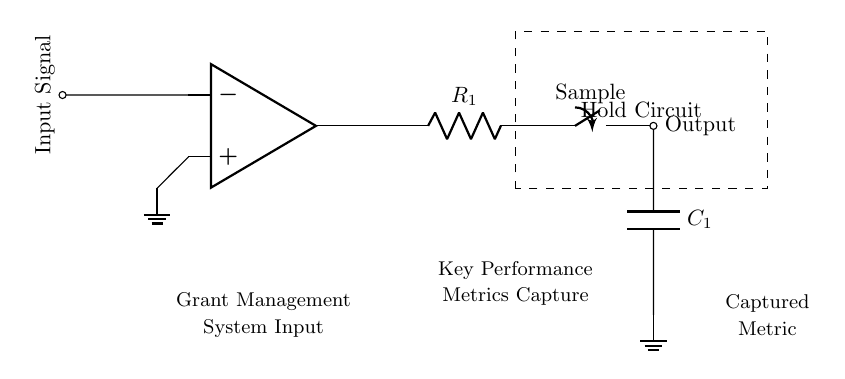What component is used to hold the captured signal? The circuit includes a capacitor, labeled C1, which is typically used in sample-and-hold circuits to hold the voltage level of the input signal.
Answer: Capacitor What is the main function of the switch in the circuit? The switch allows the circuit to operate in two modes: sampling the input signal when closed and holding the captured value when open, effectively controlling the operation of the sample-and-hold circuit.
Answer: Sample What type of operational amplifier is shown in the diagram? The circuit utilizes a standard operational amplifier, which amplifies the input voltage signal for processing in the sample-and-hold function.
Answer: Operational amplifier What does the dashed rectangle represent in the diagram? The dashed rectangle encloses the hold circuit, indicating it is a specific section handling the storage of the sampled signal, separating it visually from other components of the circuit.
Answer: Hold circuit How many resistors are present in this circuit? There is one resistor (R1) noted in the circuit diagram that is involved in the signal processing pathway.
Answer: One What role does the ground play in this circuit? The ground serves as a reference point for the voltages in the circuit, stabilizing the circuit operations and ensuring that the measured signals relative to this ground level are accurate.
Answer: Reference point 